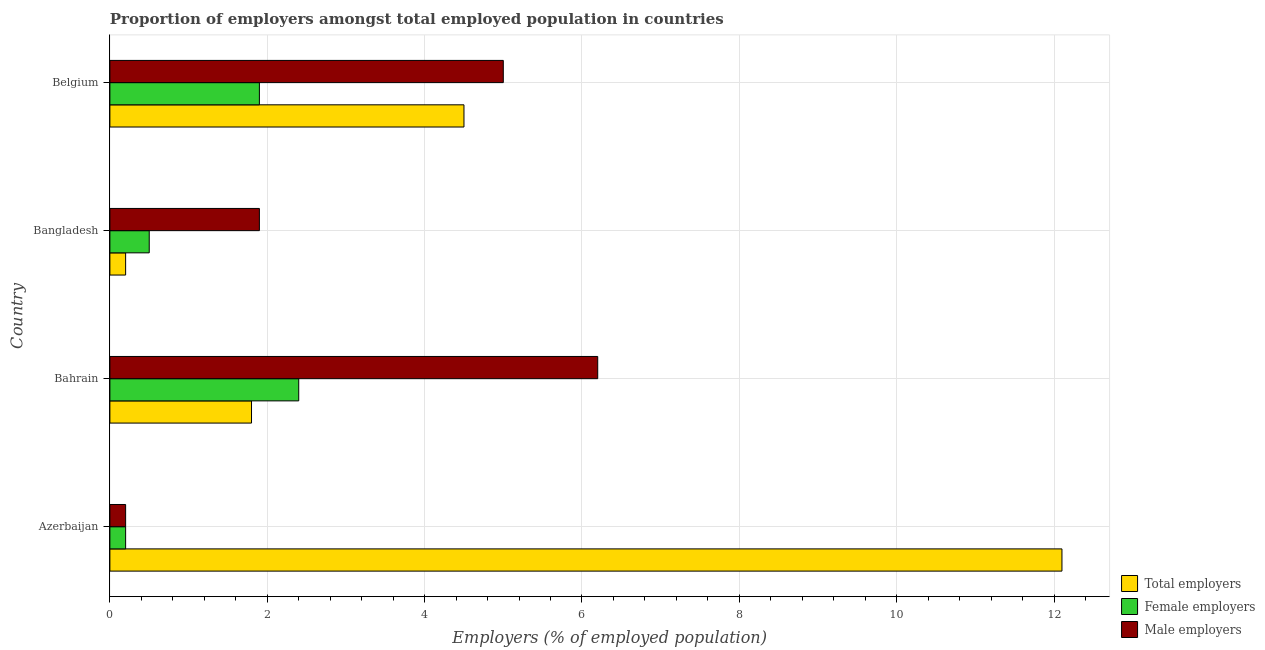How many groups of bars are there?
Provide a succinct answer. 4. Are the number of bars per tick equal to the number of legend labels?
Offer a very short reply. Yes. How many bars are there on the 2nd tick from the top?
Offer a terse response. 3. What is the label of the 3rd group of bars from the top?
Your answer should be compact. Bahrain. What is the percentage of total employers in Azerbaijan?
Your response must be concise. 12.1. Across all countries, what is the maximum percentage of total employers?
Your answer should be compact. 12.1. Across all countries, what is the minimum percentage of total employers?
Offer a very short reply. 0.2. In which country was the percentage of female employers maximum?
Keep it short and to the point. Bahrain. In which country was the percentage of male employers minimum?
Offer a terse response. Azerbaijan. What is the total percentage of female employers in the graph?
Ensure brevity in your answer.  5. What is the difference between the percentage of total employers in Azerbaijan and that in Bangladesh?
Provide a short and direct response. 11.9. What is the difference between the percentage of female employers in Bahrain and the percentage of male employers in Azerbaijan?
Your answer should be compact. 2.2. What is the average percentage of male employers per country?
Make the answer very short. 3.33. What is the ratio of the percentage of male employers in Bahrain to that in Bangladesh?
Your response must be concise. 3.26. Is the percentage of female employers in Azerbaijan less than that in Bangladesh?
Give a very brief answer. Yes. What is the difference between the highest and the lowest percentage of male employers?
Ensure brevity in your answer.  6. What does the 2nd bar from the top in Belgium represents?
Make the answer very short. Female employers. What does the 2nd bar from the bottom in Bangladesh represents?
Ensure brevity in your answer.  Female employers. Are all the bars in the graph horizontal?
Make the answer very short. Yes. How many countries are there in the graph?
Give a very brief answer. 4. Are the values on the major ticks of X-axis written in scientific E-notation?
Ensure brevity in your answer.  No. Does the graph contain grids?
Your response must be concise. Yes. Where does the legend appear in the graph?
Offer a terse response. Bottom right. How many legend labels are there?
Ensure brevity in your answer.  3. What is the title of the graph?
Offer a terse response. Proportion of employers amongst total employed population in countries. Does "Ireland" appear as one of the legend labels in the graph?
Offer a terse response. No. What is the label or title of the X-axis?
Your answer should be compact. Employers (% of employed population). What is the label or title of the Y-axis?
Keep it short and to the point. Country. What is the Employers (% of employed population) of Total employers in Azerbaijan?
Offer a very short reply. 12.1. What is the Employers (% of employed population) in Female employers in Azerbaijan?
Your answer should be very brief. 0.2. What is the Employers (% of employed population) in Male employers in Azerbaijan?
Your response must be concise. 0.2. What is the Employers (% of employed population) of Total employers in Bahrain?
Make the answer very short. 1.8. What is the Employers (% of employed population) in Female employers in Bahrain?
Provide a short and direct response. 2.4. What is the Employers (% of employed population) of Male employers in Bahrain?
Ensure brevity in your answer.  6.2. What is the Employers (% of employed population) of Total employers in Bangladesh?
Your response must be concise. 0.2. What is the Employers (% of employed population) of Female employers in Bangladesh?
Offer a very short reply. 0.5. What is the Employers (% of employed population) of Male employers in Bangladesh?
Your answer should be very brief. 1.9. What is the Employers (% of employed population) of Female employers in Belgium?
Give a very brief answer. 1.9. Across all countries, what is the maximum Employers (% of employed population) in Total employers?
Offer a terse response. 12.1. Across all countries, what is the maximum Employers (% of employed population) of Female employers?
Your response must be concise. 2.4. Across all countries, what is the maximum Employers (% of employed population) in Male employers?
Your answer should be compact. 6.2. Across all countries, what is the minimum Employers (% of employed population) in Total employers?
Offer a terse response. 0.2. Across all countries, what is the minimum Employers (% of employed population) in Female employers?
Your response must be concise. 0.2. Across all countries, what is the minimum Employers (% of employed population) of Male employers?
Keep it short and to the point. 0.2. What is the total Employers (% of employed population) in Total employers in the graph?
Your answer should be compact. 18.6. What is the total Employers (% of employed population) of Male employers in the graph?
Offer a terse response. 13.3. What is the difference between the Employers (% of employed population) of Female employers in Azerbaijan and that in Bahrain?
Ensure brevity in your answer.  -2.2. What is the difference between the Employers (% of employed population) in Total employers in Azerbaijan and that in Bangladesh?
Make the answer very short. 11.9. What is the difference between the Employers (% of employed population) of Female employers in Azerbaijan and that in Bangladesh?
Your answer should be very brief. -0.3. What is the difference between the Employers (% of employed population) in Male employers in Azerbaijan and that in Bangladesh?
Your answer should be very brief. -1.7. What is the difference between the Employers (% of employed population) of Total employers in Azerbaijan and that in Belgium?
Give a very brief answer. 7.6. What is the difference between the Employers (% of employed population) of Male employers in Bahrain and that in Bangladesh?
Offer a very short reply. 4.3. What is the difference between the Employers (% of employed population) of Female employers in Bahrain and that in Belgium?
Keep it short and to the point. 0.5. What is the difference between the Employers (% of employed population) of Male employers in Bahrain and that in Belgium?
Your answer should be compact. 1.2. What is the difference between the Employers (% of employed population) of Female employers in Bangladesh and that in Belgium?
Make the answer very short. -1.4. What is the difference between the Employers (% of employed population) in Total employers in Azerbaijan and the Employers (% of employed population) in Female employers in Bahrain?
Your answer should be compact. 9.7. What is the difference between the Employers (% of employed population) in Total employers in Azerbaijan and the Employers (% of employed population) in Male employers in Bahrain?
Offer a terse response. 5.9. What is the difference between the Employers (% of employed population) of Total employers in Azerbaijan and the Employers (% of employed population) of Female employers in Bangladesh?
Offer a terse response. 11.6. What is the difference between the Employers (% of employed population) of Total employers in Azerbaijan and the Employers (% of employed population) of Male employers in Bangladesh?
Your answer should be very brief. 10.2. What is the difference between the Employers (% of employed population) of Total employers in Azerbaijan and the Employers (% of employed population) of Female employers in Belgium?
Your answer should be very brief. 10.2. What is the difference between the Employers (% of employed population) of Female employers in Azerbaijan and the Employers (% of employed population) of Male employers in Belgium?
Your answer should be compact. -4.8. What is the difference between the Employers (% of employed population) of Total employers in Bahrain and the Employers (% of employed population) of Female employers in Bangladesh?
Offer a very short reply. 1.3. What is the difference between the Employers (% of employed population) of Female employers in Bahrain and the Employers (% of employed population) of Male employers in Bangladesh?
Keep it short and to the point. 0.5. What is the difference between the Employers (% of employed population) of Female employers in Bahrain and the Employers (% of employed population) of Male employers in Belgium?
Offer a terse response. -2.6. What is the difference between the Employers (% of employed population) in Total employers in Bangladesh and the Employers (% of employed population) in Male employers in Belgium?
Your response must be concise. -4.8. What is the average Employers (% of employed population) of Total employers per country?
Provide a short and direct response. 4.65. What is the average Employers (% of employed population) of Female employers per country?
Offer a very short reply. 1.25. What is the average Employers (% of employed population) in Male employers per country?
Keep it short and to the point. 3.33. What is the difference between the Employers (% of employed population) of Total employers and Employers (% of employed population) of Female employers in Azerbaijan?
Your response must be concise. 11.9. What is the difference between the Employers (% of employed population) of Total employers and Employers (% of employed population) of Male employers in Bahrain?
Your answer should be compact. -4.4. What is the difference between the Employers (% of employed population) in Female employers and Employers (% of employed population) in Male employers in Bahrain?
Offer a terse response. -3.8. What is the difference between the Employers (% of employed population) of Total employers and Employers (% of employed population) of Female employers in Bangladesh?
Give a very brief answer. -0.3. What is the difference between the Employers (% of employed population) of Female employers and Employers (% of employed population) of Male employers in Bangladesh?
Offer a very short reply. -1.4. What is the difference between the Employers (% of employed population) of Total employers and Employers (% of employed population) of Female employers in Belgium?
Offer a terse response. 2.6. What is the difference between the Employers (% of employed population) of Total employers and Employers (% of employed population) of Male employers in Belgium?
Make the answer very short. -0.5. What is the ratio of the Employers (% of employed population) in Total employers in Azerbaijan to that in Bahrain?
Ensure brevity in your answer.  6.72. What is the ratio of the Employers (% of employed population) of Female employers in Azerbaijan to that in Bahrain?
Your answer should be very brief. 0.08. What is the ratio of the Employers (% of employed population) of Male employers in Azerbaijan to that in Bahrain?
Offer a very short reply. 0.03. What is the ratio of the Employers (% of employed population) of Total employers in Azerbaijan to that in Bangladesh?
Make the answer very short. 60.5. What is the ratio of the Employers (% of employed population) of Female employers in Azerbaijan to that in Bangladesh?
Offer a terse response. 0.4. What is the ratio of the Employers (% of employed population) of Male employers in Azerbaijan to that in Bangladesh?
Your answer should be compact. 0.11. What is the ratio of the Employers (% of employed population) of Total employers in Azerbaijan to that in Belgium?
Offer a very short reply. 2.69. What is the ratio of the Employers (% of employed population) in Female employers in Azerbaijan to that in Belgium?
Make the answer very short. 0.11. What is the ratio of the Employers (% of employed population) of Total employers in Bahrain to that in Bangladesh?
Your answer should be very brief. 9. What is the ratio of the Employers (% of employed population) in Male employers in Bahrain to that in Bangladesh?
Offer a very short reply. 3.26. What is the ratio of the Employers (% of employed population) of Female employers in Bahrain to that in Belgium?
Your response must be concise. 1.26. What is the ratio of the Employers (% of employed population) of Male employers in Bahrain to that in Belgium?
Provide a short and direct response. 1.24. What is the ratio of the Employers (% of employed population) in Total employers in Bangladesh to that in Belgium?
Ensure brevity in your answer.  0.04. What is the ratio of the Employers (% of employed population) in Female employers in Bangladesh to that in Belgium?
Offer a terse response. 0.26. What is the ratio of the Employers (% of employed population) of Male employers in Bangladesh to that in Belgium?
Provide a succinct answer. 0.38. What is the difference between the highest and the second highest Employers (% of employed population) in Female employers?
Your answer should be compact. 0.5. What is the difference between the highest and the second highest Employers (% of employed population) of Male employers?
Provide a short and direct response. 1.2. What is the difference between the highest and the lowest Employers (% of employed population) of Total employers?
Keep it short and to the point. 11.9. What is the difference between the highest and the lowest Employers (% of employed population) in Male employers?
Provide a short and direct response. 6. 